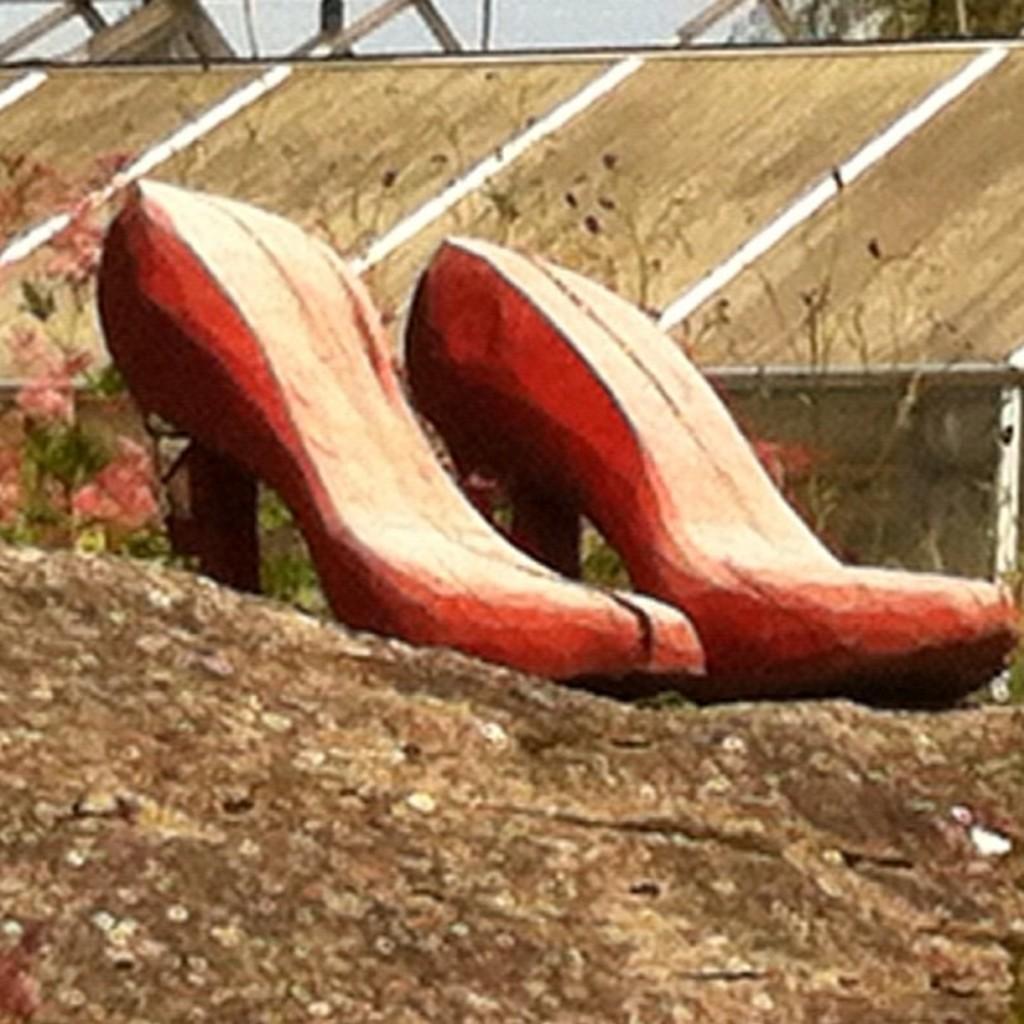In one or two sentences, can you explain what this image depicts? In the picture we can see a rock path on it we can see a pair of heels which are red in color and besides it we can see some flowers to the plants and in the background we can see a wall and sky from it. 